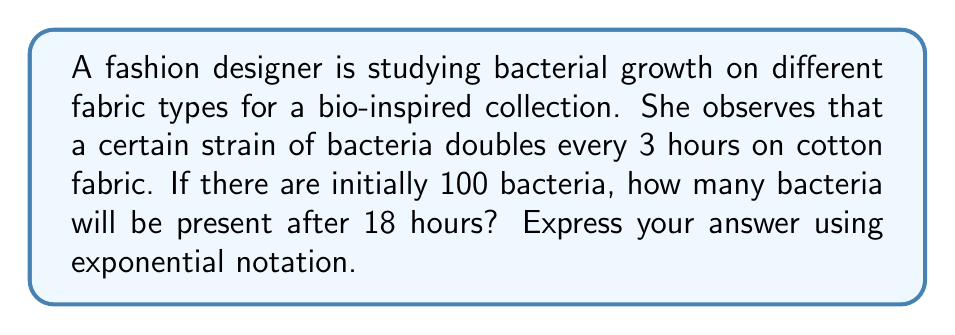Help me with this question. Let's approach this step-by-step:

1) We're dealing with exponential growth. The general formula for exponential growth is:

   $A = P(1 + r)^t$

   Where:
   $A$ = final amount
   $P$ = initial amount
   $r$ = growth rate
   $t$ = time

2) In this case, we're given:
   $P = 100$ (initial number of bacteria)
   The population doubles every 3 hours, so $t = 18/3 = 6$ (number of doubling periods in 18 hours)

3) When a population doubles, it grows by 100% or 1. So our growth rate $r = 1$.

4) We can simplify our formula to:

   $A = P(2)^t$

5) Plugging in our values:

   $A = 100(2)^6$

6) Simplify:
   
   $A = 100 * 64 = 6400$

7) Express in exponential notation:

   $A = 6.4 * 10^3$
Answer: $6.4 * 10^3$ bacteria 